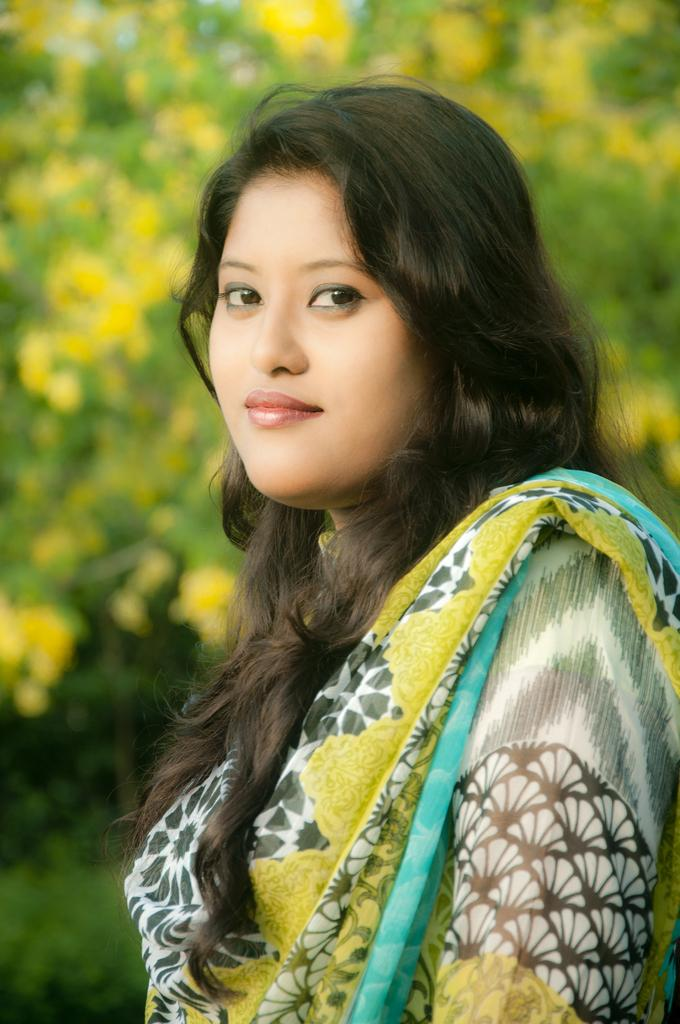Who is the main subject in the image? There is a woman in the image. What is the woman wearing? The woman is wearing a colorful dress. Can you describe the colors of the dress? The dress is predominantly yellow and green. What is the color scheme of the background in the image? The background of the image is yellow and green. Where is the faucet located in the image? There is no faucet present in the image. How many geese are flying in the image? There are no geese present in the image. 